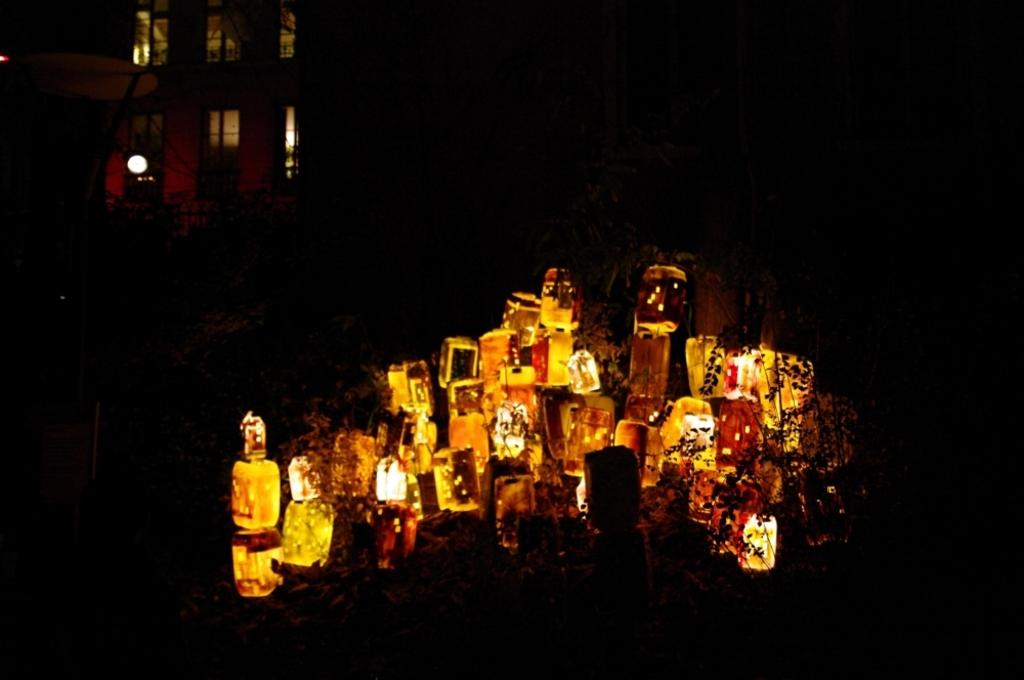What can be seen in the image that provides illumination? There are lights in the image. What type of living organisms are present in the image? There are plants in the image. What can be seen in the background of the image? There is a building in the background of the image. How many snakes are wrapped around the plants in the image? There are no snakes present in the image; it only features plants and lights. What type of plants are being watered by the hose in the image? There is no hose present in the image, so it is not possible to determine what type of plants are being watered. 